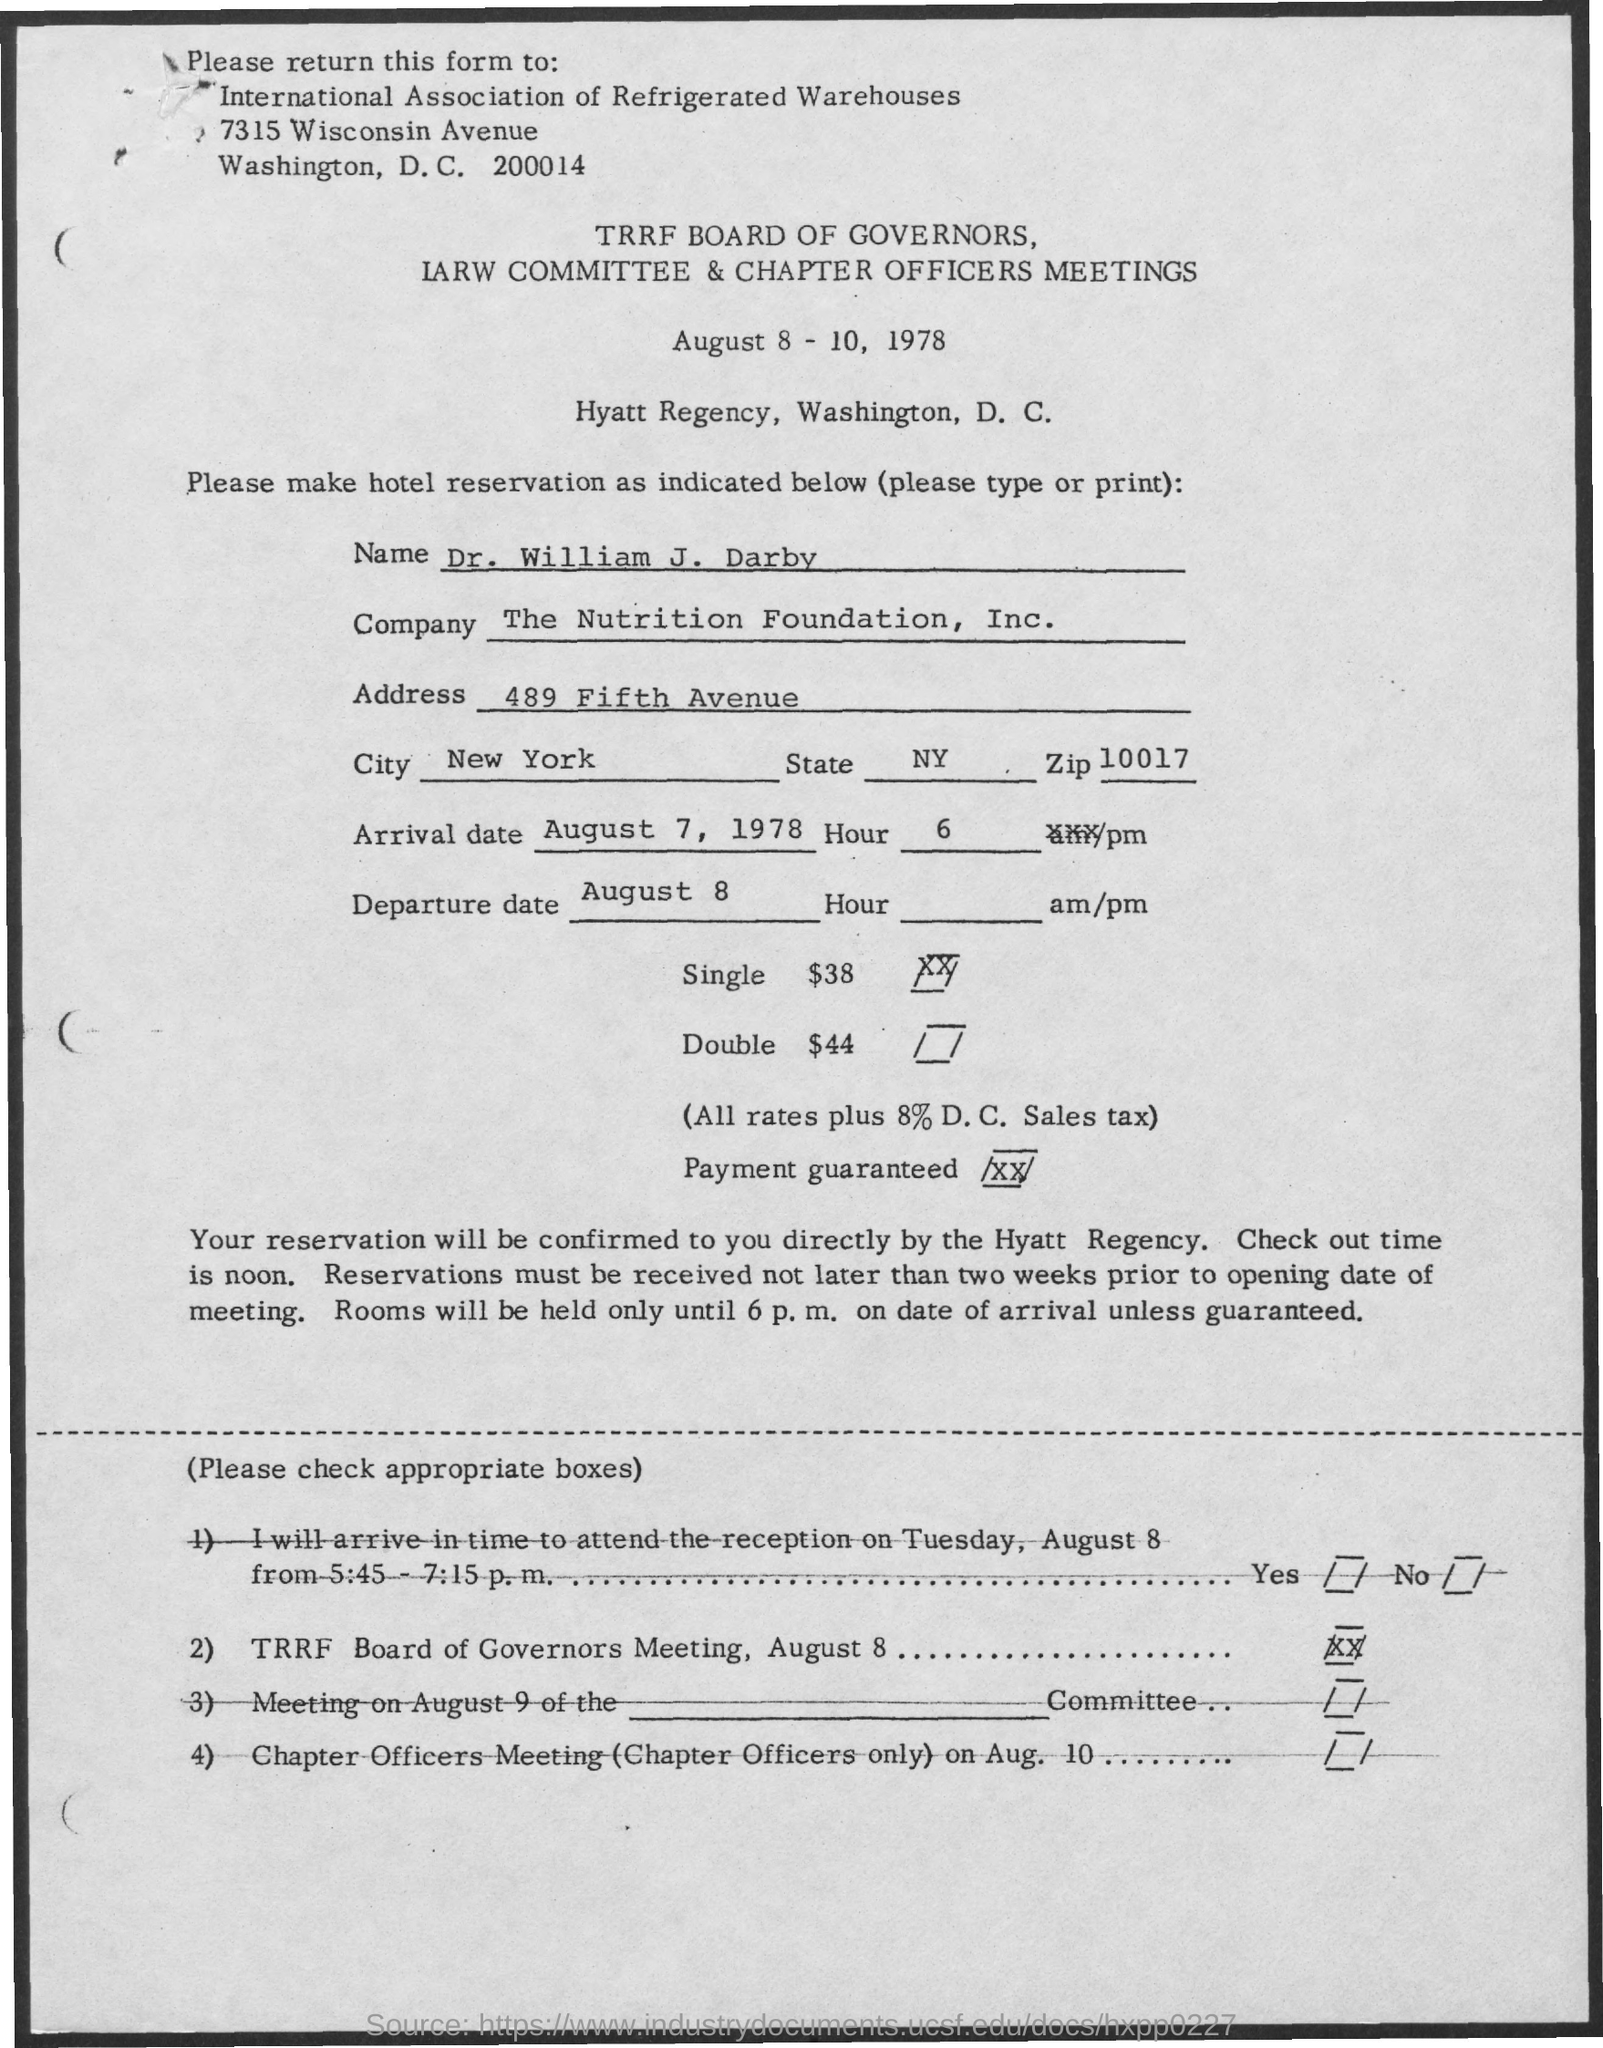Highlight a few significant elements in this photo. The state of New York is... The arrival date is August 7, 1978. What is the City? New York, specifically, is the city in question. The meeting will take place at the Hyatt Regency located in Washington, D.C. The Zip code is 10017. 